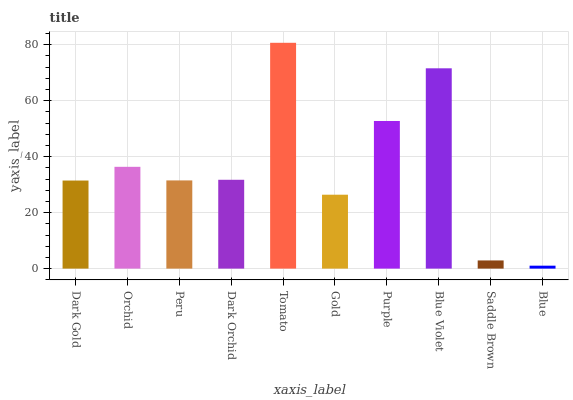Is Orchid the minimum?
Answer yes or no. No. Is Orchid the maximum?
Answer yes or no. No. Is Orchid greater than Dark Gold?
Answer yes or no. Yes. Is Dark Gold less than Orchid?
Answer yes or no. Yes. Is Dark Gold greater than Orchid?
Answer yes or no. No. Is Orchid less than Dark Gold?
Answer yes or no. No. Is Dark Orchid the high median?
Answer yes or no. Yes. Is Peru the low median?
Answer yes or no. Yes. Is Purple the high median?
Answer yes or no. No. Is Dark Gold the low median?
Answer yes or no. No. 